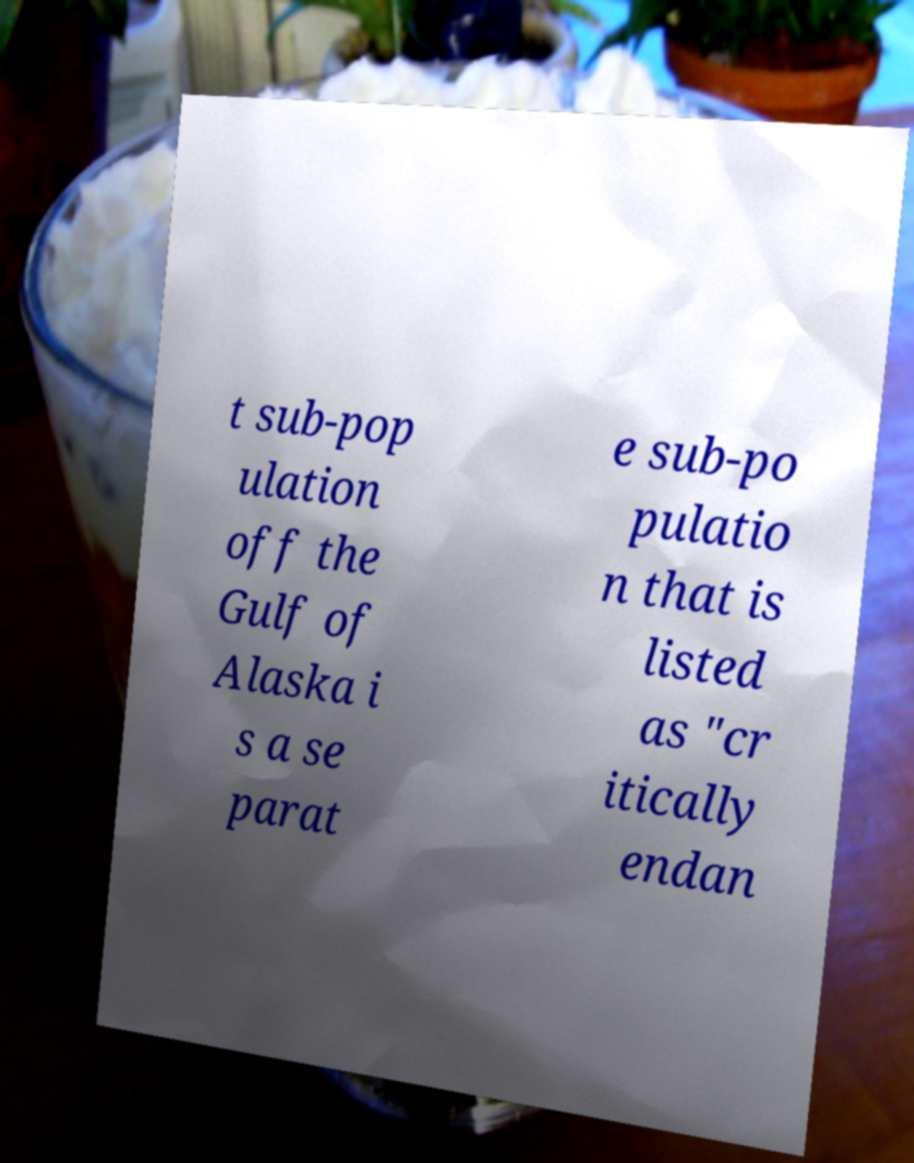Please identify and transcribe the text found in this image. t sub-pop ulation off the Gulf of Alaska i s a se parat e sub-po pulatio n that is listed as "cr itically endan 